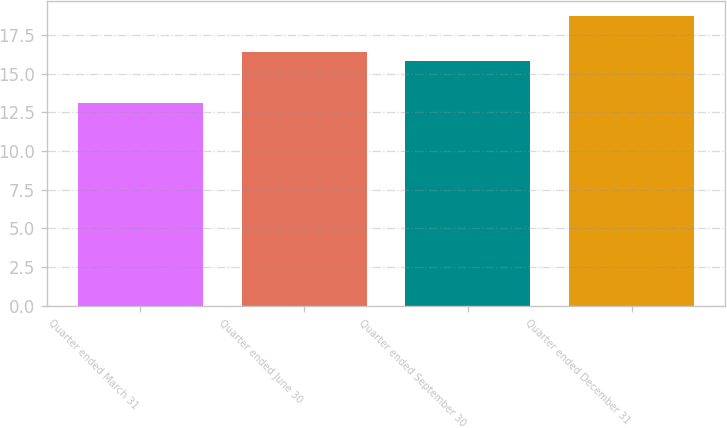Convert chart to OTSL. <chart><loc_0><loc_0><loc_500><loc_500><bar_chart><fcel>Quarter ended March 31<fcel>Quarter ended June 30<fcel>Quarter ended September 30<fcel>Quarter ended December 31<nl><fcel>13.12<fcel>16.41<fcel>15.85<fcel>18.75<nl></chart> 